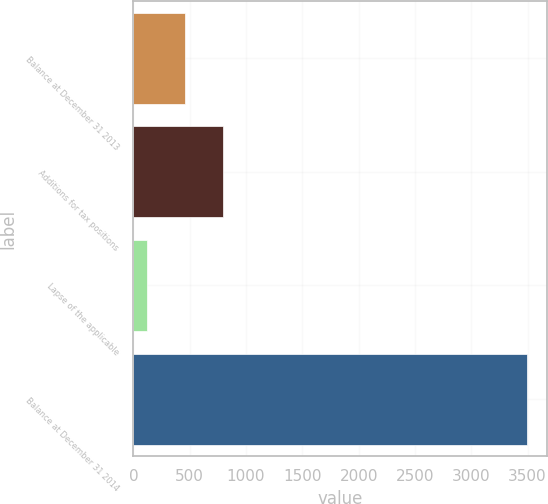<chart> <loc_0><loc_0><loc_500><loc_500><bar_chart><fcel>Balance at December 31 2013<fcel>Additions for tax positions<fcel>Lapse of the applicable<fcel>Balance at December 31 2014<nl><fcel>458.6<fcel>796.2<fcel>121<fcel>3497<nl></chart> 